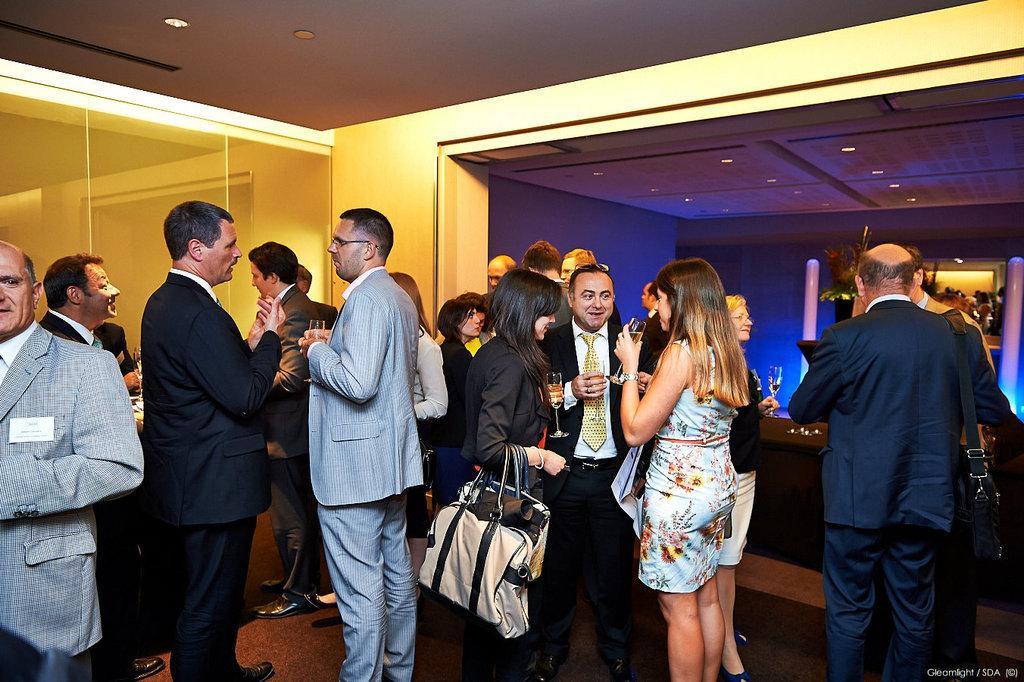How would you summarize this image in a sentence or two? In this picture few people standing and few of them holdings in there hands and a woman wore couple of bags and I can see lights to the ceiling and text at the bottom right corner of the picture. 